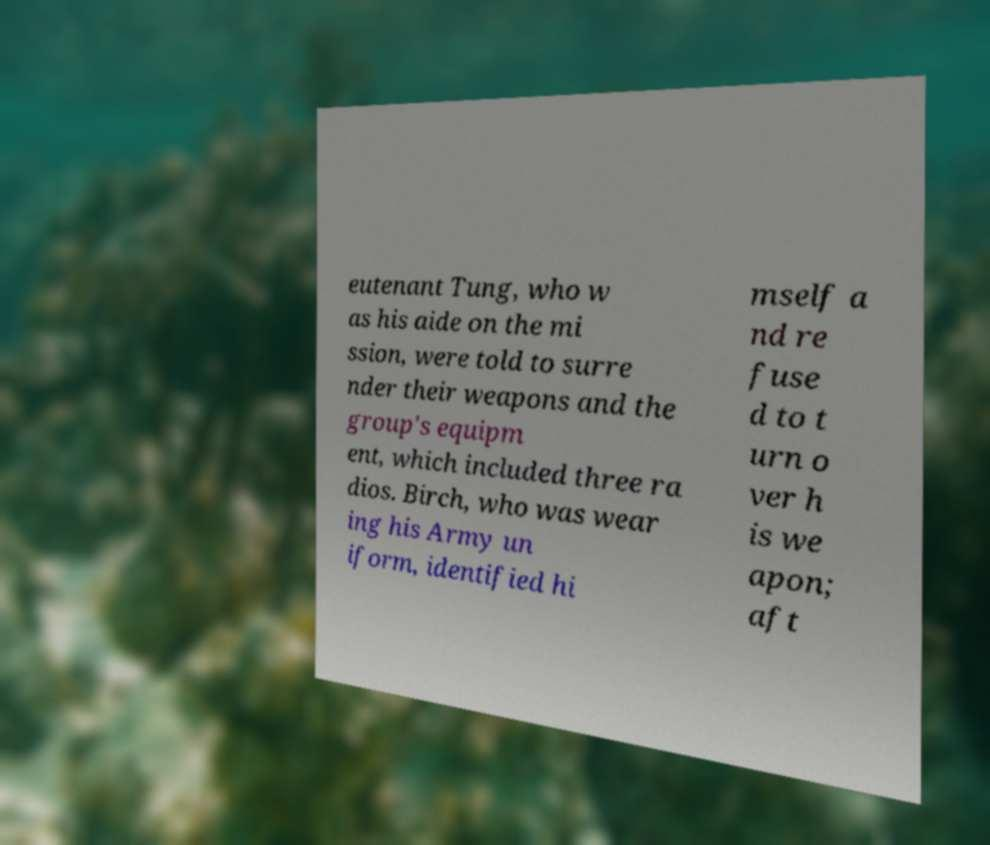Can you accurately transcribe the text from the provided image for me? eutenant Tung, who w as his aide on the mi ssion, were told to surre nder their weapons and the group's equipm ent, which included three ra dios. Birch, who was wear ing his Army un iform, identified hi mself a nd re fuse d to t urn o ver h is we apon; aft 